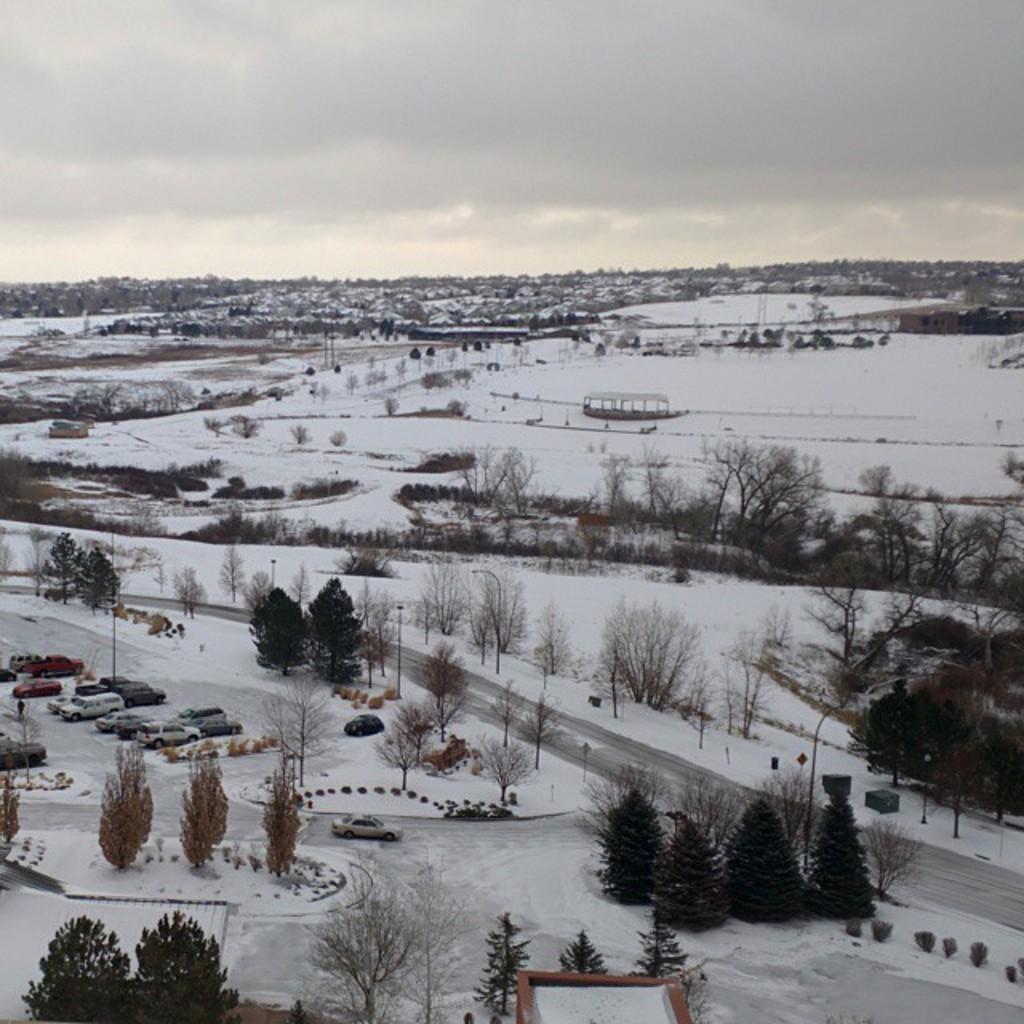Please provide a concise description of this image. In this image we can see many trees, road and vehicles. And it is covered with snow. In the background there is sky. 